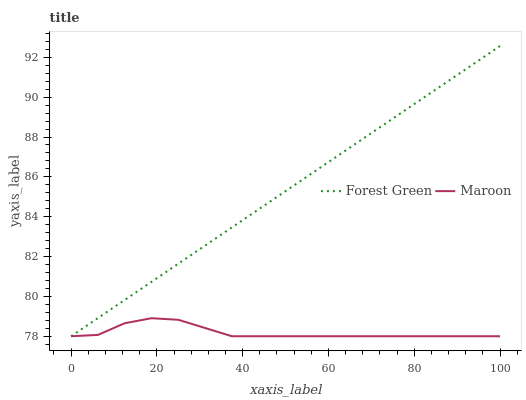Does Maroon have the minimum area under the curve?
Answer yes or no. Yes. Does Forest Green have the maximum area under the curve?
Answer yes or no. Yes. Does Maroon have the maximum area under the curve?
Answer yes or no. No. Is Forest Green the smoothest?
Answer yes or no. Yes. Is Maroon the roughest?
Answer yes or no. Yes. Is Maroon the smoothest?
Answer yes or no. No. Does Forest Green have the lowest value?
Answer yes or no. Yes. Does Forest Green have the highest value?
Answer yes or no. Yes. Does Maroon have the highest value?
Answer yes or no. No. Does Maroon intersect Forest Green?
Answer yes or no. Yes. Is Maroon less than Forest Green?
Answer yes or no. No. Is Maroon greater than Forest Green?
Answer yes or no. No. 